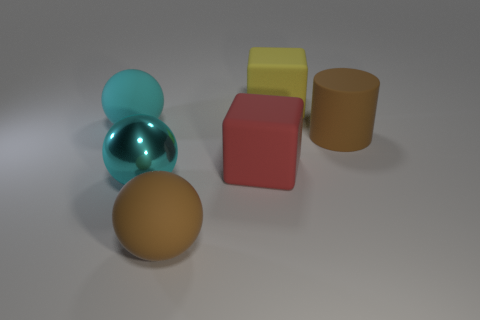Add 3 red things. How many objects exist? 9 Subtract all cylinders. How many objects are left? 5 Subtract all blue metallic balls. Subtract all large red blocks. How many objects are left? 5 Add 3 large rubber blocks. How many large rubber blocks are left? 5 Add 1 green balls. How many green balls exist? 1 Subtract 0 purple balls. How many objects are left? 6 